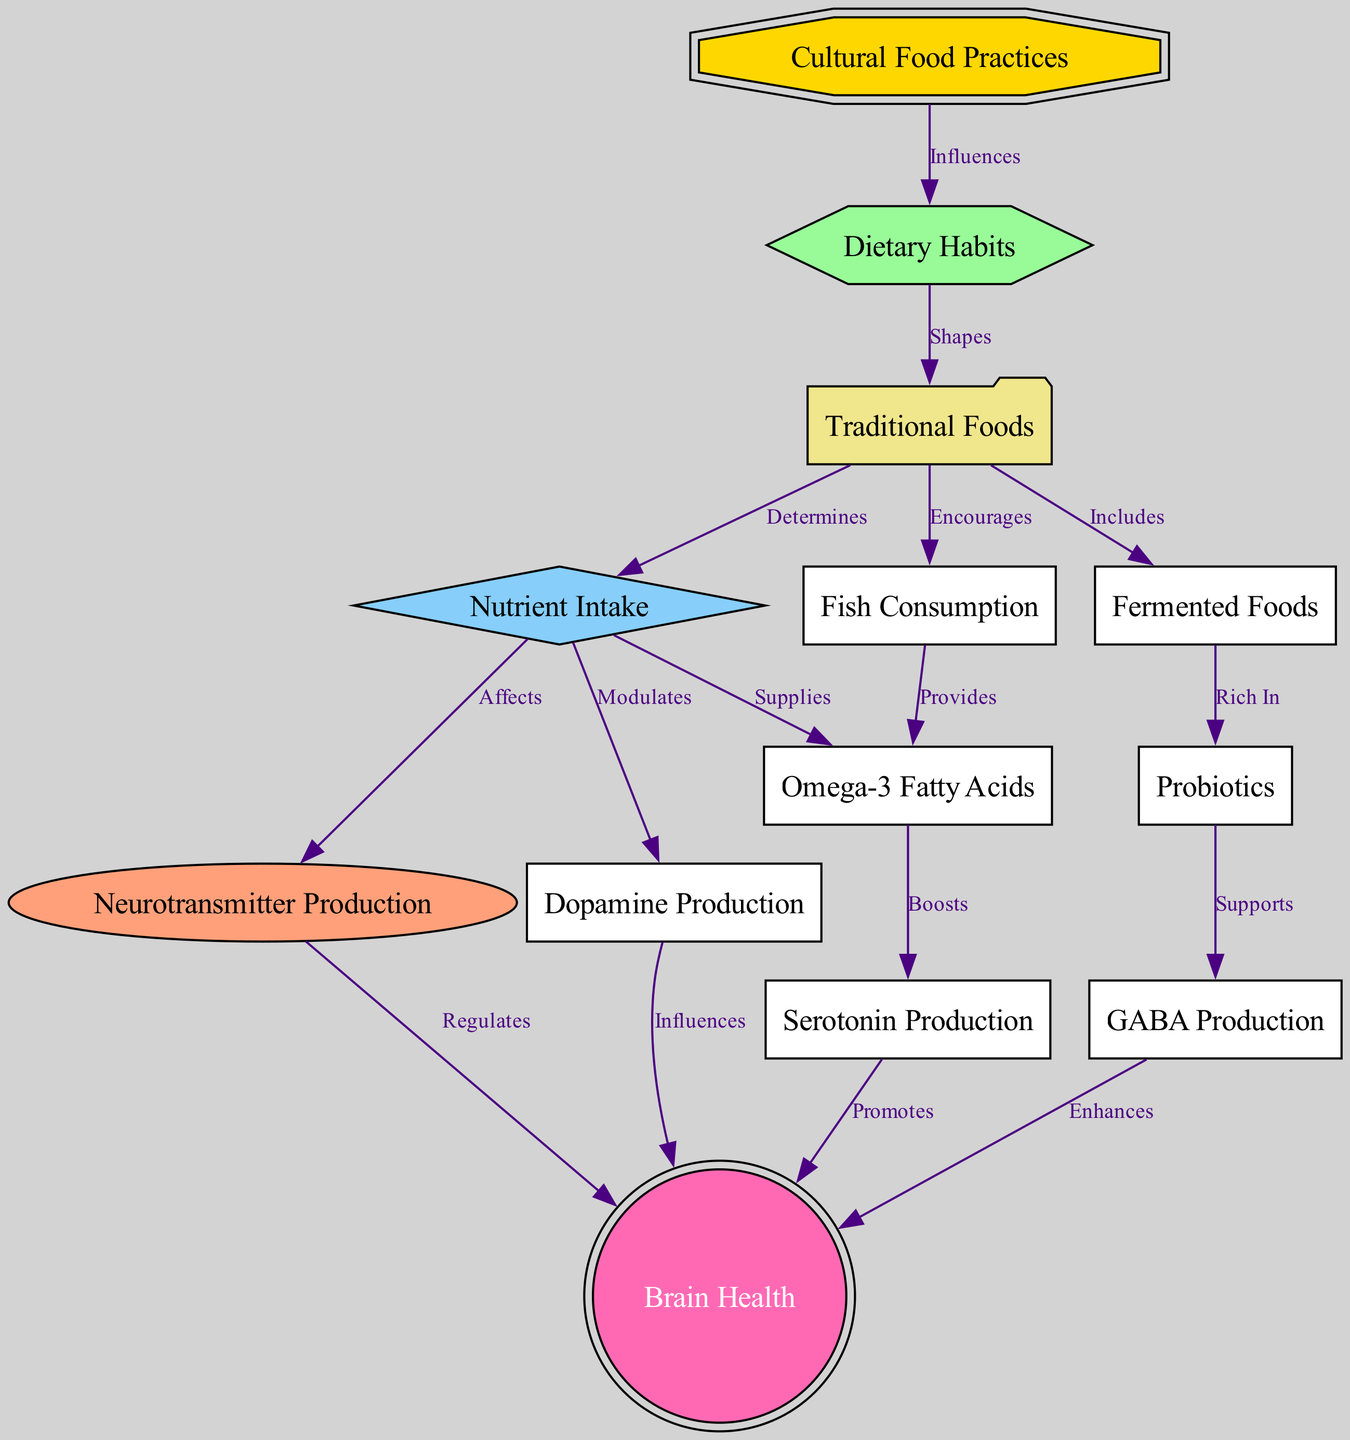What is the first node in the diagram? The first node is "Cultural Food Practices," which directly influences dietary habits. It is typically listed at the top of the diagram.
Answer: Cultural Food Practices How many nodes are in the diagram? The diagram has a total of 13 nodes. This can be counted by simply listing the unique terms presented in the nodes section.
Answer: 13 What does "Dietary Habits" shape? "Dietary Habits" shapes "Traditional Foods," as indicated by the directional edge labeled as "Shapes." This shows the influence of dietary habits on the types of traditional foods consumed.
Answer: Traditional Foods What nutrient does "Nutrient Intake" supply? "Nutrient Intake" supplies "Omega-3 Fatty Acids," indicated by the edge labeled "Supplies" that connects the two nodes. This specifies a direct relationship between nutrient intake and omega-3 fatty acids.
Answer: Omega-3 Fatty Acids What enhances brain health according to the diagram? According to the diagram, "GABA Production" enhances brain health, as connected by the edge labeled "Enhances" between the two nodes. This indicates that GABA production impacts brain health positively.
Answer: GABA Production How does "Traditional Foods" influence "Brain Health"? "Traditional Foods" influences brain health indirectly through several nodes: it determines "Nutrient Intake," which affects "Neurotransmitter Production," and ultimately, neurotransmitter production regulates "Brain Health." This chain of influence demonstrates the pathway.
Answer: Indirectly through several nodes What do "Fermented Foods" support? "Fermented Foods" support "Probiotics," as shown by the direct edge labeled "Rich In," indicating that this type of food is particularly abundant in probiotics.
Answer: Probiotics Which neurotransmitter production is modulated by nutrient intake? The modulation indicated shows that "Dopamine Production" is modulated by "Nutrient Intake," represented by the direct relationship labeled "Modulates." This highlights a connection between nutrition and the production of dopamine.
Answer: Dopamine Production What are "Fermented Foods" rich in? "Fermented Foods" are rich in "Probiotics," based on the edge labeled "Rich In," which defines the characteristics of fermented foods in terms of their content.
Answer: Probiotics 